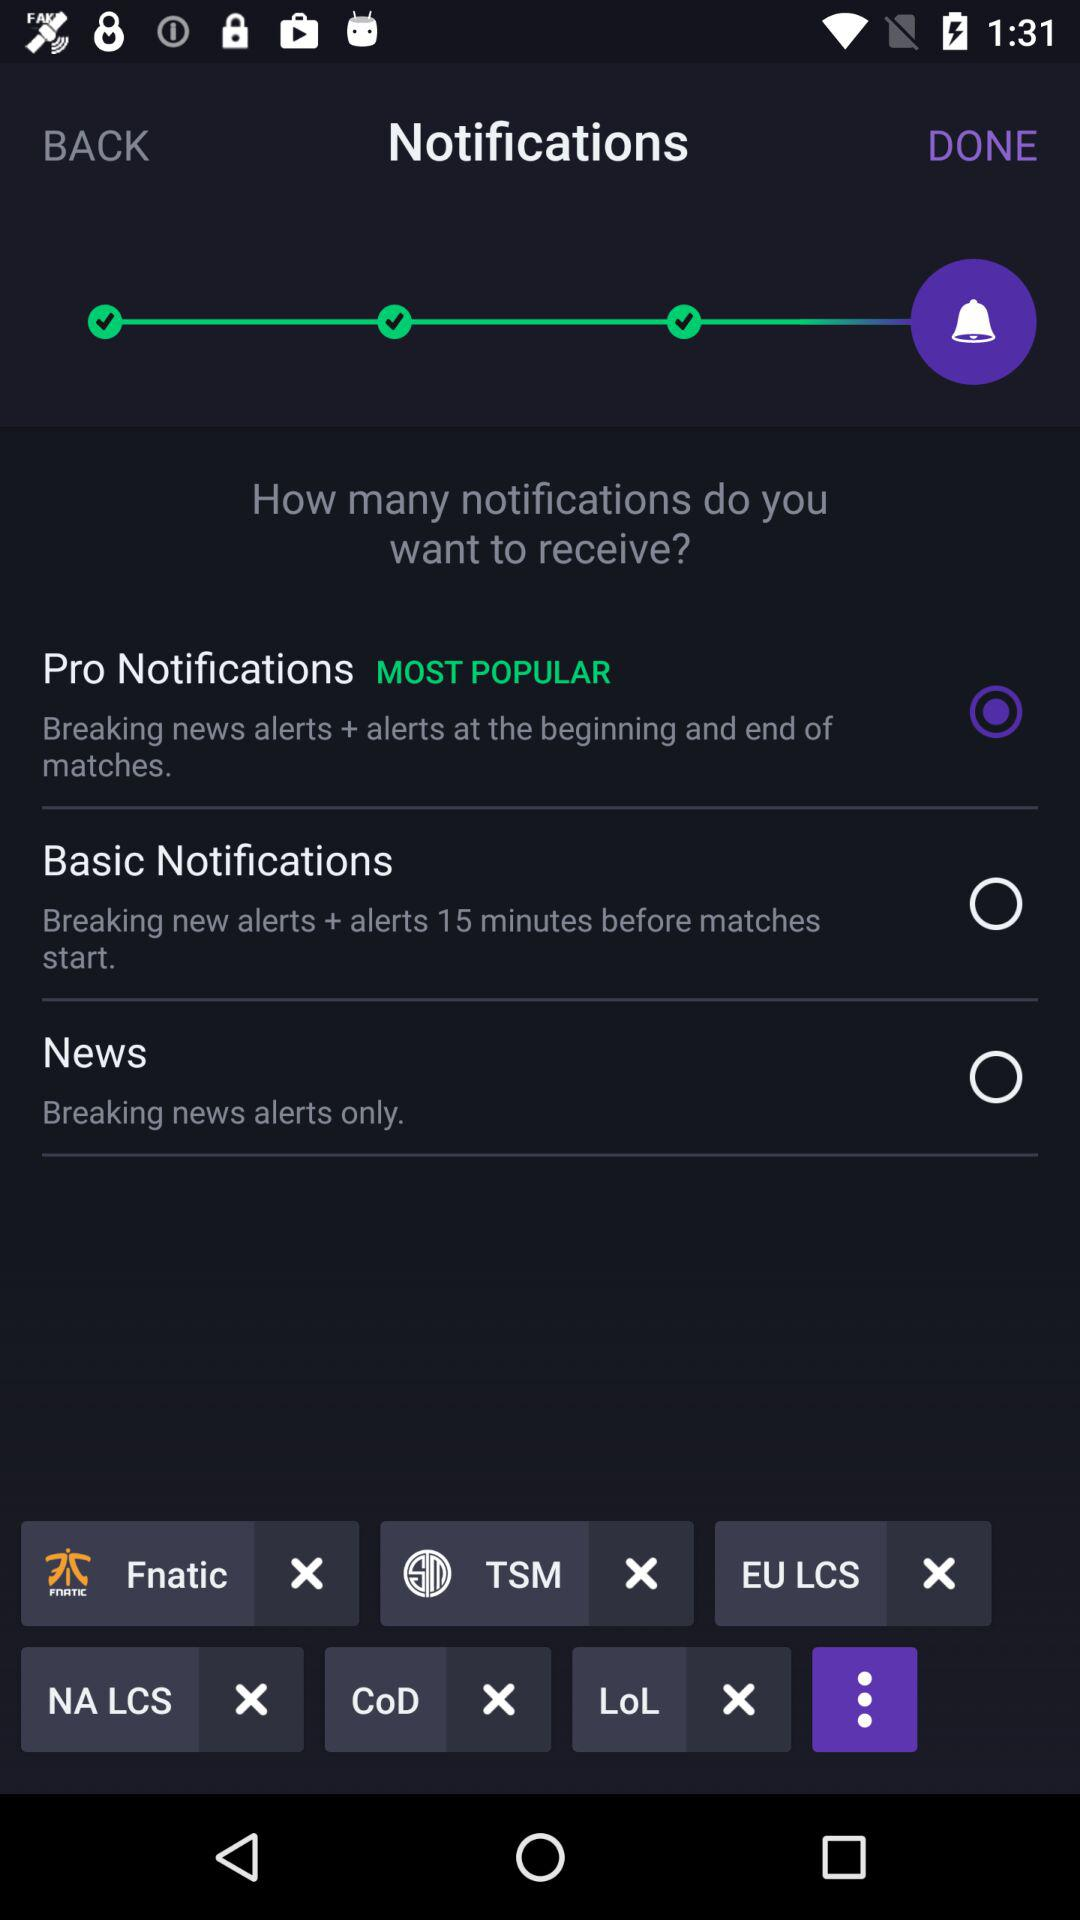What is the status of basic notifications? The status is "off". 